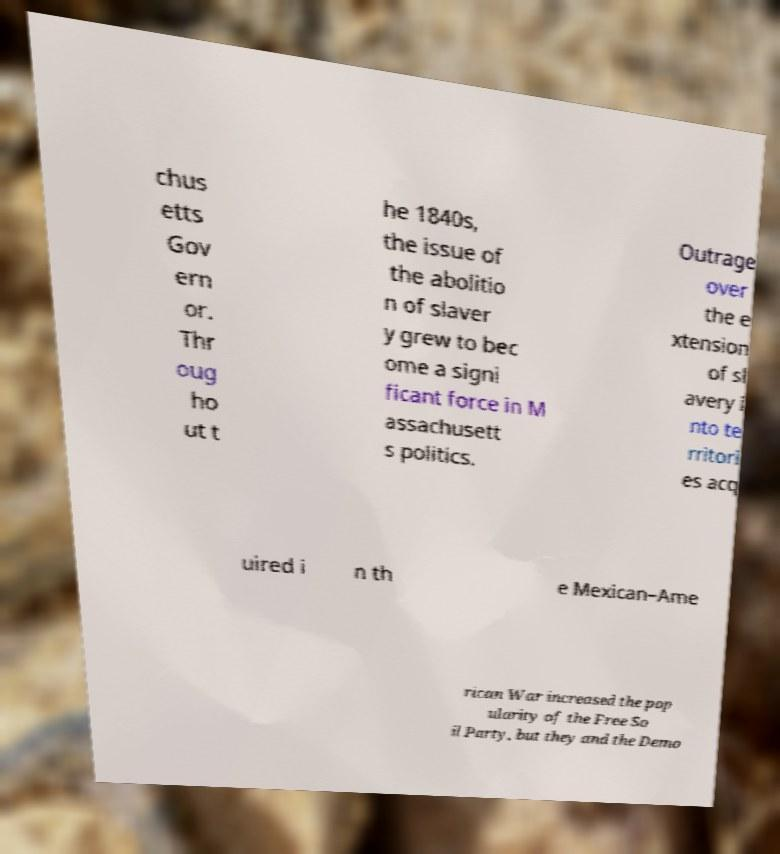Can you accurately transcribe the text from the provided image for me? chus etts Gov ern or. Thr oug ho ut t he 1840s, the issue of the abolitio n of slaver y grew to bec ome a signi ficant force in M assachusett s politics. Outrage over the e xtension of sl avery i nto te rritori es acq uired i n th e Mexican–Ame rican War increased the pop ularity of the Free So il Party, but they and the Demo 